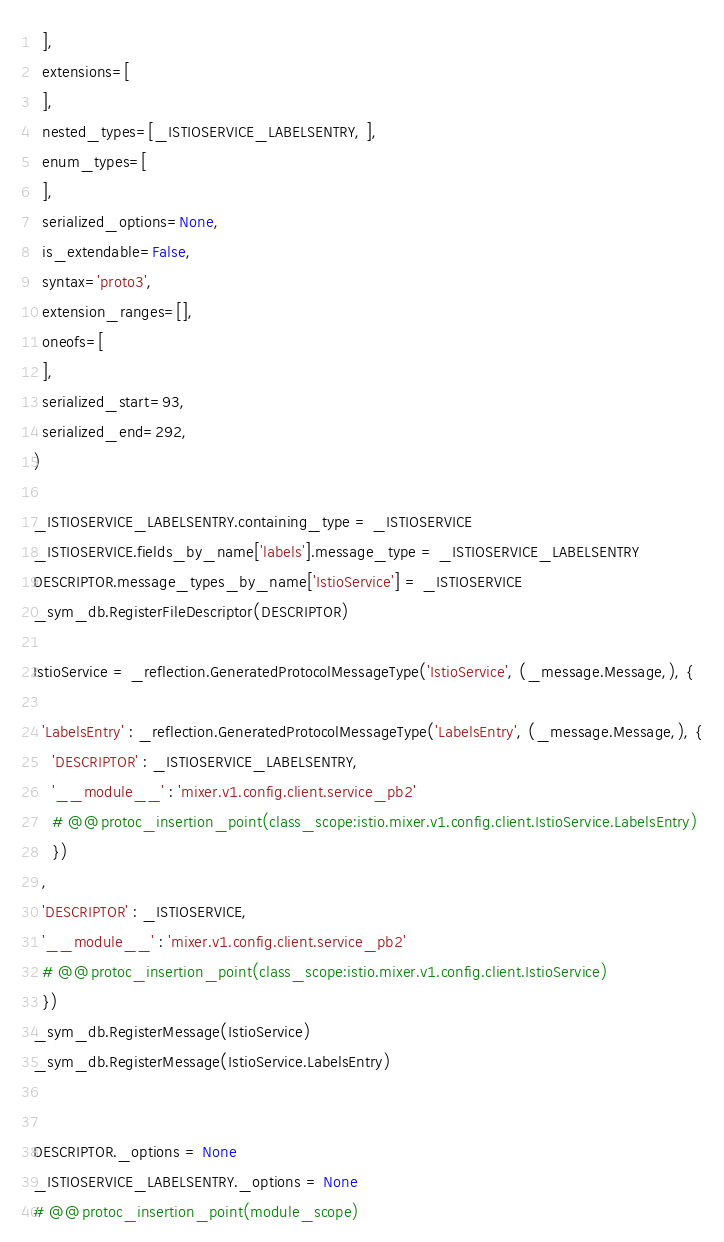Convert code to text. <code><loc_0><loc_0><loc_500><loc_500><_Python_>  ],
  extensions=[
  ],
  nested_types=[_ISTIOSERVICE_LABELSENTRY, ],
  enum_types=[
  ],
  serialized_options=None,
  is_extendable=False,
  syntax='proto3',
  extension_ranges=[],
  oneofs=[
  ],
  serialized_start=93,
  serialized_end=292,
)

_ISTIOSERVICE_LABELSENTRY.containing_type = _ISTIOSERVICE
_ISTIOSERVICE.fields_by_name['labels'].message_type = _ISTIOSERVICE_LABELSENTRY
DESCRIPTOR.message_types_by_name['IstioService'] = _ISTIOSERVICE
_sym_db.RegisterFileDescriptor(DESCRIPTOR)

IstioService = _reflection.GeneratedProtocolMessageType('IstioService', (_message.Message,), {

  'LabelsEntry' : _reflection.GeneratedProtocolMessageType('LabelsEntry', (_message.Message,), {
    'DESCRIPTOR' : _ISTIOSERVICE_LABELSENTRY,
    '__module__' : 'mixer.v1.config.client.service_pb2'
    # @@protoc_insertion_point(class_scope:istio.mixer.v1.config.client.IstioService.LabelsEntry)
    })
  ,
  'DESCRIPTOR' : _ISTIOSERVICE,
  '__module__' : 'mixer.v1.config.client.service_pb2'
  # @@protoc_insertion_point(class_scope:istio.mixer.v1.config.client.IstioService)
  })
_sym_db.RegisterMessage(IstioService)
_sym_db.RegisterMessage(IstioService.LabelsEntry)


DESCRIPTOR._options = None
_ISTIOSERVICE_LABELSENTRY._options = None
# @@protoc_insertion_point(module_scope)
</code> 